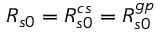<formula> <loc_0><loc_0><loc_500><loc_500>R _ { s 0 } = R _ { s 0 } ^ { c s } = R _ { s 0 } ^ { g p }</formula> 